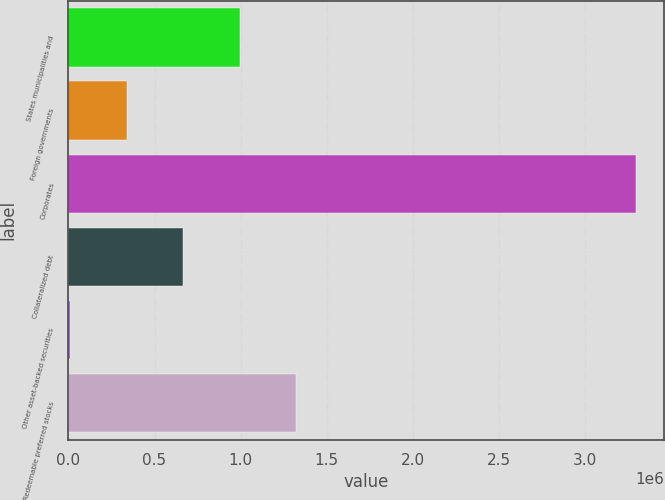Convert chart to OTSL. <chart><loc_0><loc_0><loc_500><loc_500><bar_chart><fcel>States municipalities and<fcel>Foreign governments<fcel>Corporates<fcel>Collateralized debt<fcel>Other asset-backed securities<fcel>Redeemable preferred stocks<nl><fcel>995446<fcel>339047<fcel>3.29284e+06<fcel>667246<fcel>10847<fcel>1.32365e+06<nl></chart> 